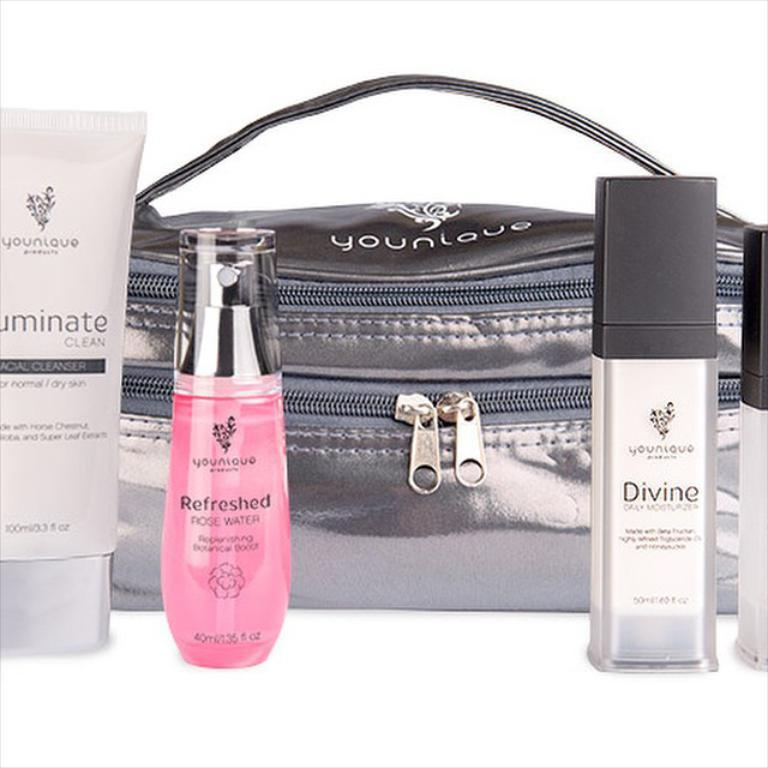<image>
Present a compact description of the photo's key features. Black Younique bag with a bottle of Refreshed rose water, and Luminate cream and a bottle of something labeled Divine displayed in front of it. 